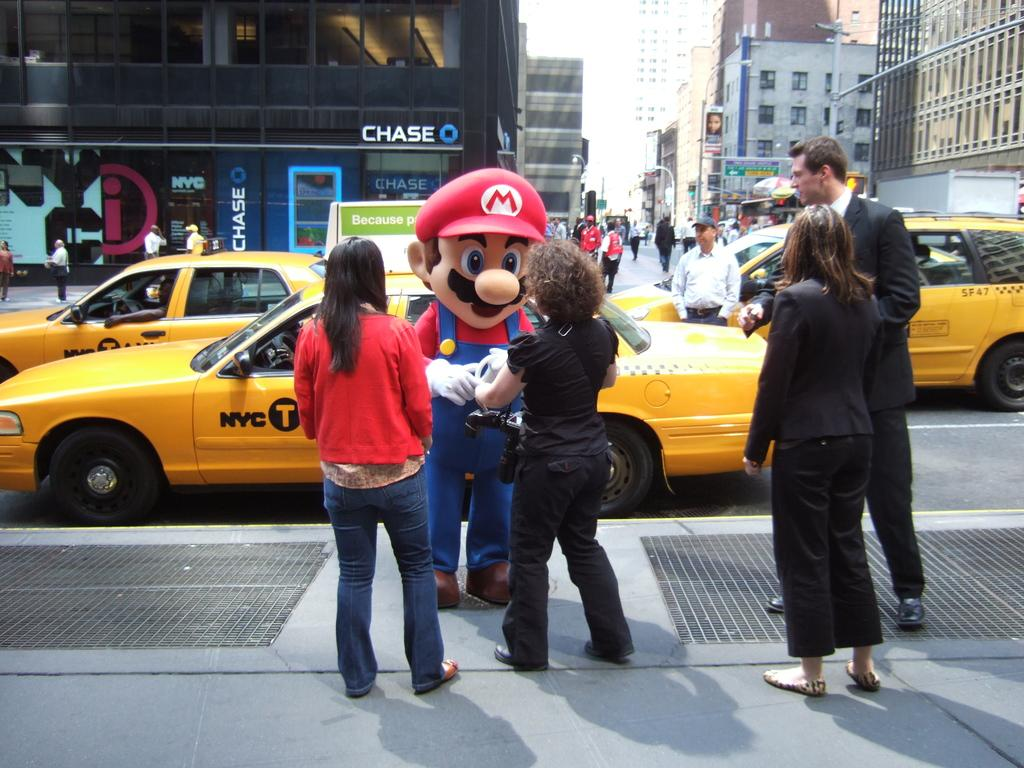<image>
Provide a brief description of the given image. A person in Super Mario costume is interacting with people on the sidewalk while yellow cabs drive by behind. 